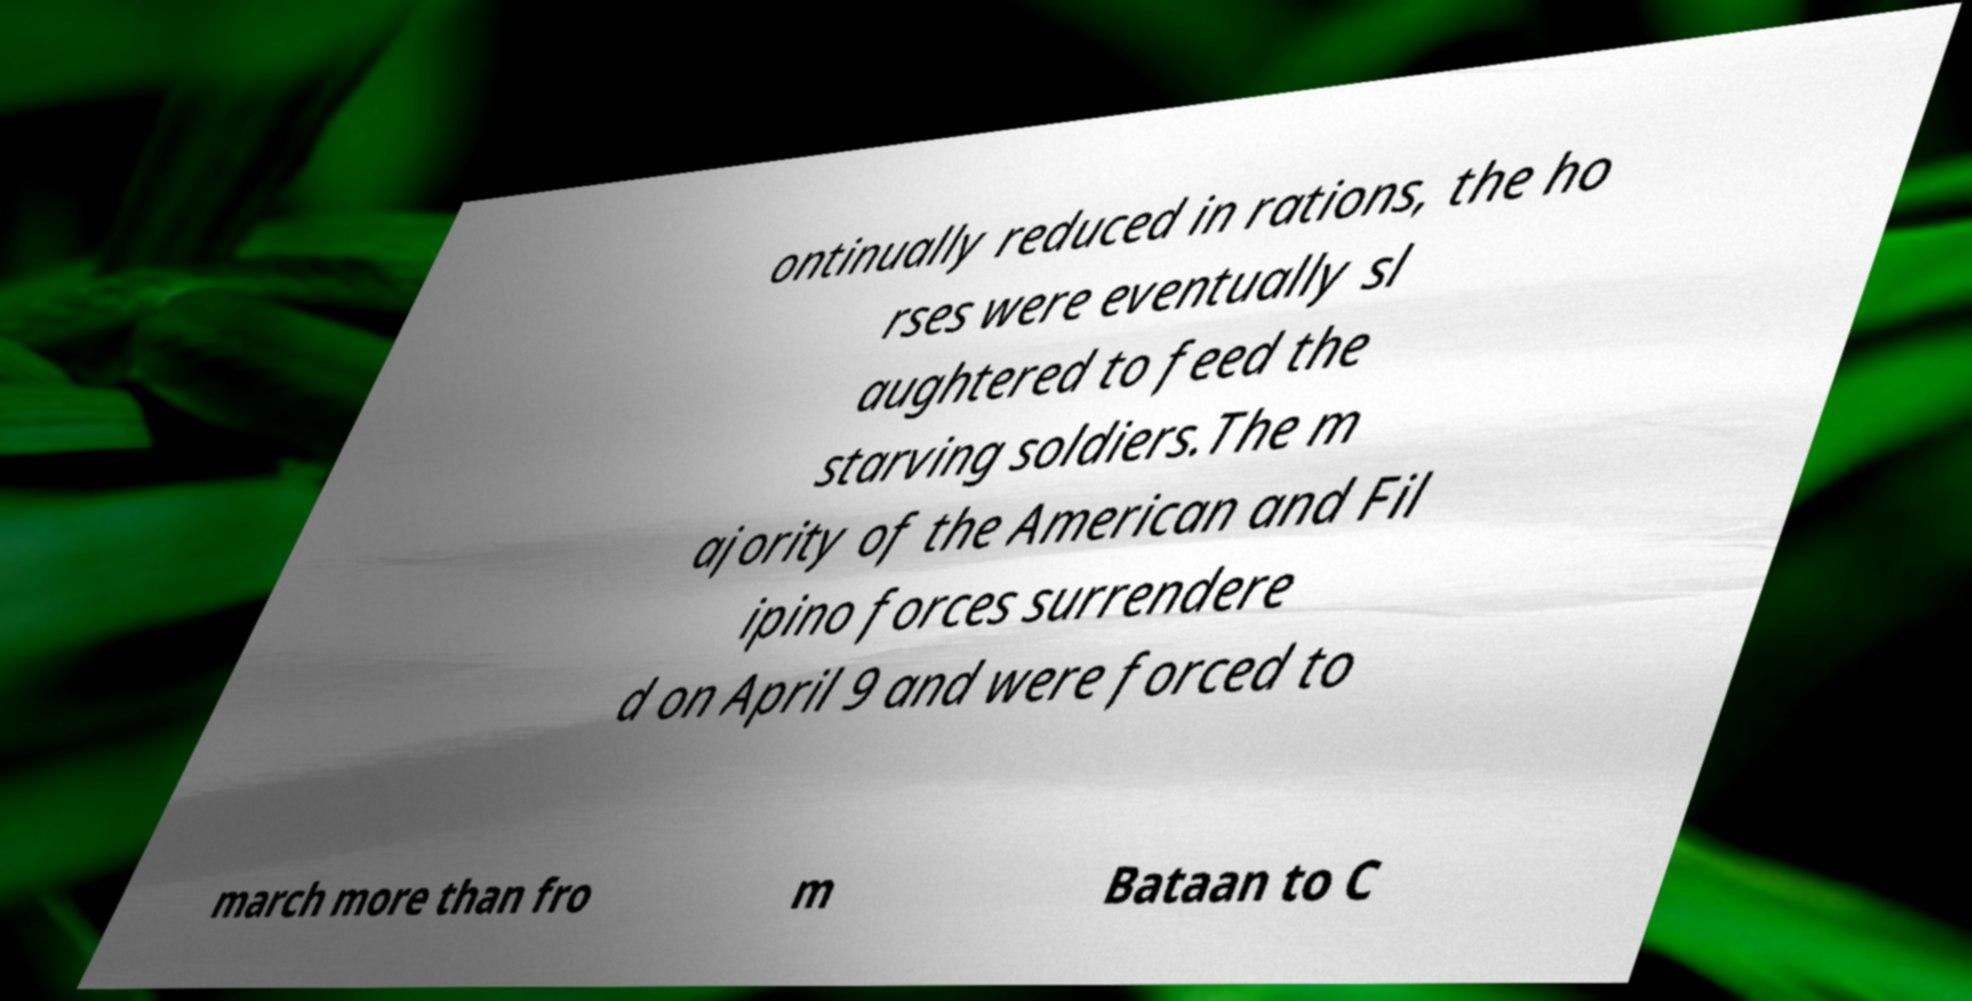Could you assist in decoding the text presented in this image and type it out clearly? ontinually reduced in rations, the ho rses were eventually sl aughtered to feed the starving soldiers.The m ajority of the American and Fil ipino forces surrendere d on April 9 and were forced to march more than fro m Bataan to C 